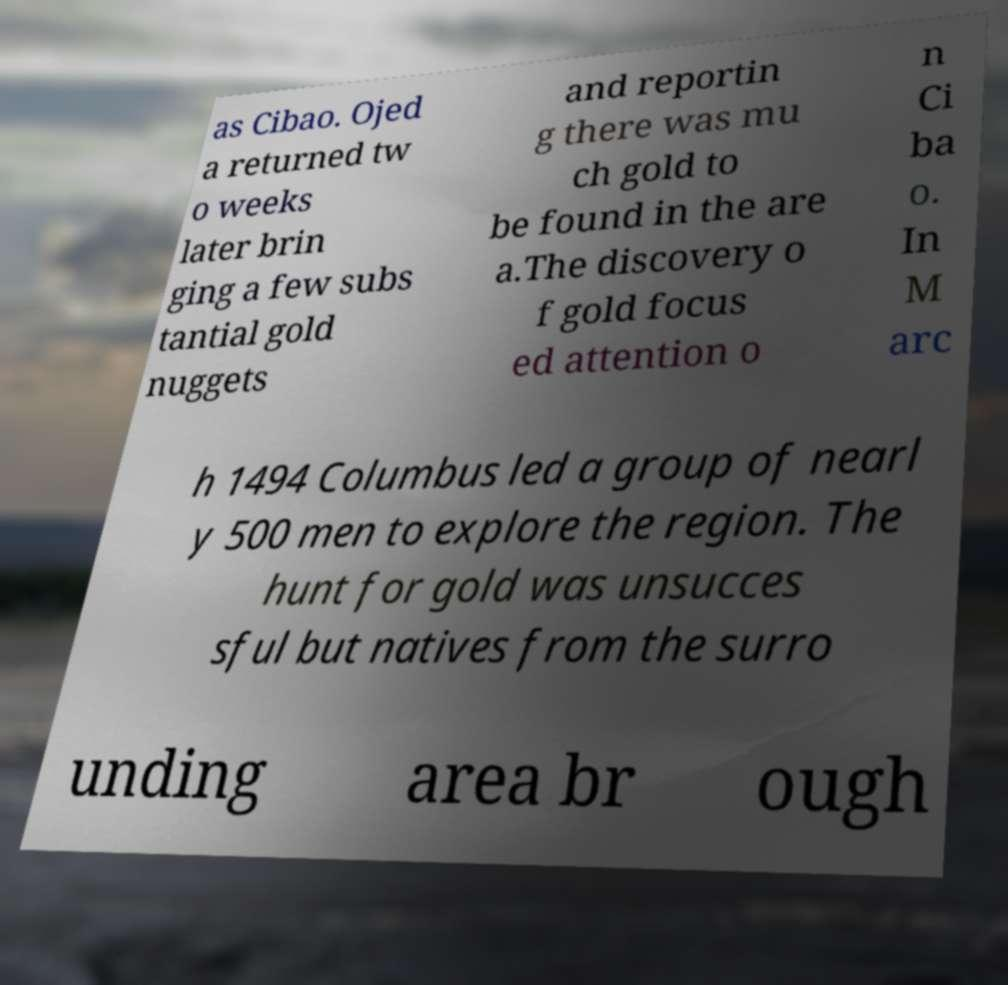Please identify and transcribe the text found in this image. as Cibao. Ojed a returned tw o weeks later brin ging a few subs tantial gold nuggets and reportin g there was mu ch gold to be found in the are a.The discovery o f gold focus ed attention o n Ci ba o. In M arc h 1494 Columbus led a group of nearl y 500 men to explore the region. The hunt for gold was unsucces sful but natives from the surro unding area br ough 